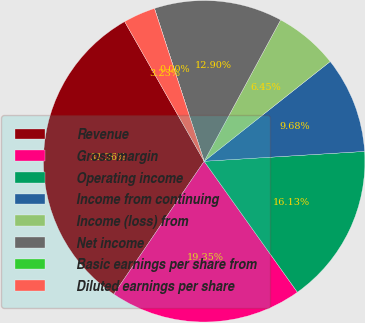<chart> <loc_0><loc_0><loc_500><loc_500><pie_chart><fcel>Revenue<fcel>Gross margin<fcel>Operating income<fcel>Income from continuing<fcel>Income (loss) from<fcel>Net income<fcel>Basic earnings per share from<fcel>Diluted earnings per share<nl><fcel>32.26%<fcel>19.35%<fcel>16.13%<fcel>9.68%<fcel>6.45%<fcel>12.9%<fcel>0.0%<fcel>3.23%<nl></chart> 